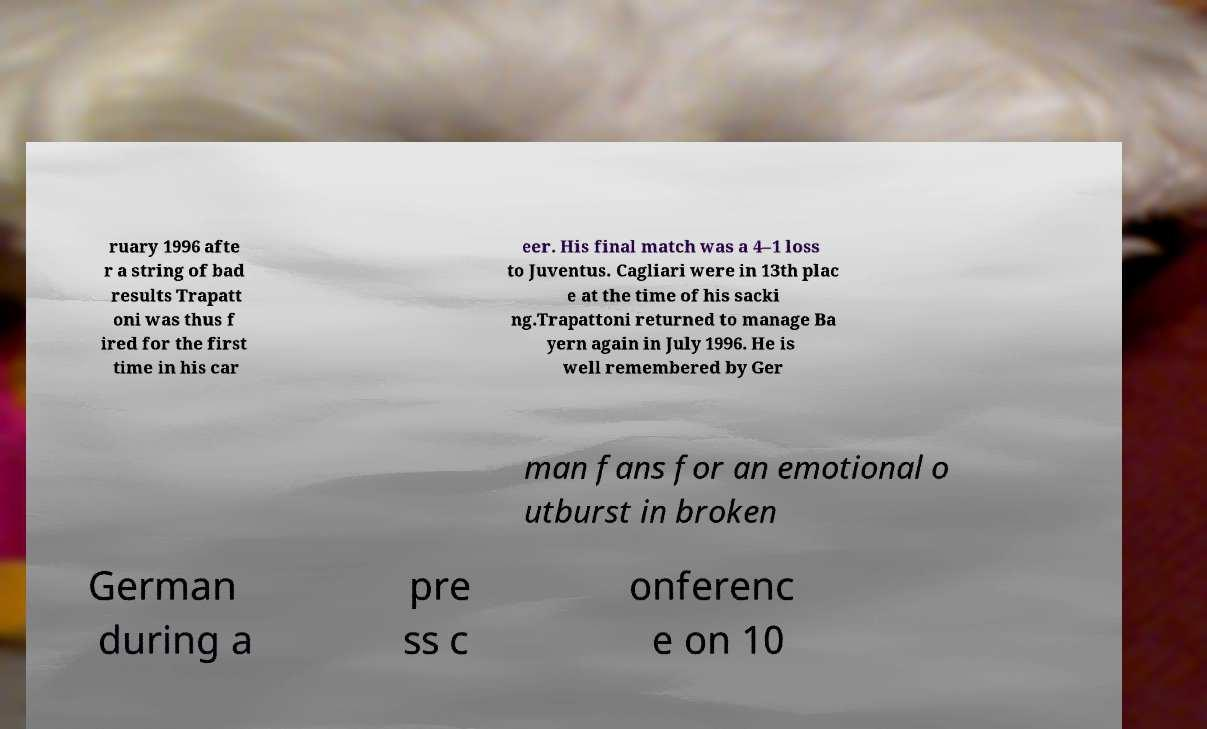What messages or text are displayed in this image? I need them in a readable, typed format. ruary 1996 afte r a string of bad results Trapatt oni was thus f ired for the first time in his car eer. His final match was a 4–1 loss to Juventus. Cagliari were in 13th plac e at the time of his sacki ng.Trapattoni returned to manage Ba yern again in July 1996. He is well remembered by Ger man fans for an emotional o utburst in broken German during a pre ss c onferenc e on 10 